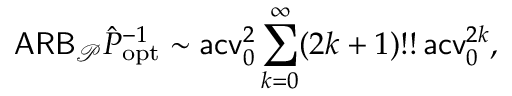Convert formula to latex. <formula><loc_0><loc_0><loc_500><loc_500>A R B _ { \mathcal { P } } \hat { P } _ { o p t } ^ { - 1 } \sim a c v _ { 0 } ^ { 2 } \sum _ { k = 0 } ^ { \infty } ( 2 k + 1 ) ! ! \, a c v _ { 0 } ^ { 2 k } ,</formula> 